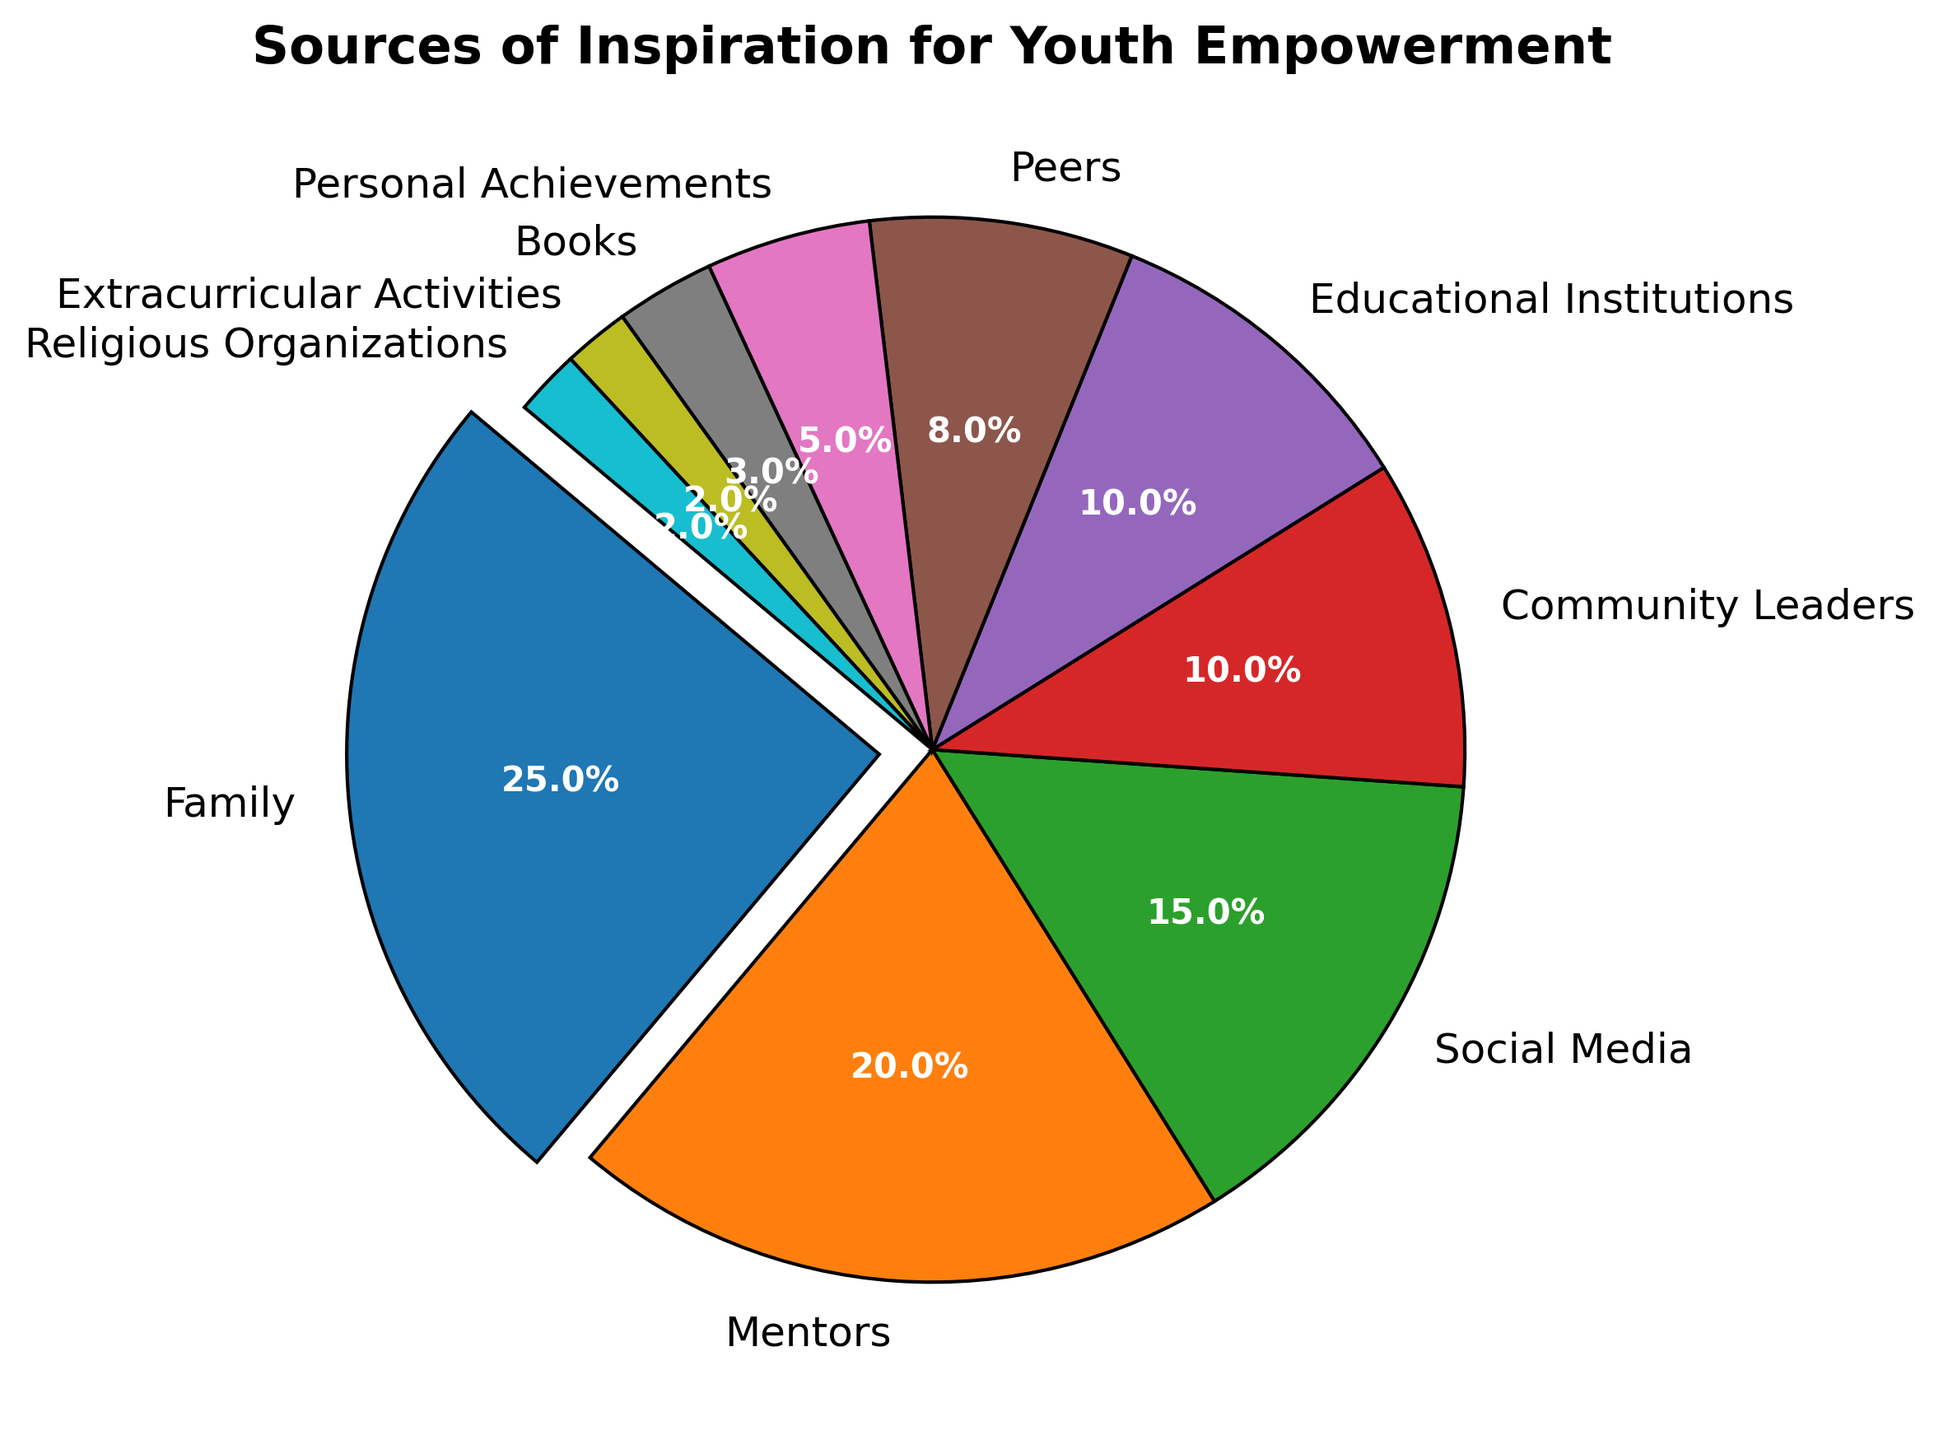What is the largest source of inspiration for youth empowerment? The pie chart shows the distribution of influences, and the largest section is clearly labeled as "Family" with 25%.
Answer: Family Which source of inspiration is the least influential? Among the listed sources, the smallest sections in the pie chart are labeled "Religious Organizations" and "Extracurricular Activities," both at 2%.
Answer: Religious Organizations and Extracurricular Activities Compare the influence of "Mentors" and "Social Media". Which one is higher? By looking at the pie chart, "Mentors" have a larger percentage (20%) compared to "Social Media," which is at 15%.
Answer: Mentors How much greater is the percentage of "Families" compared to "Community Leaders"? The slice for "Family" is 25%, while "Community Leaders" is 10%. So, 25% - 10% = 15%.
Answer: 15% What is the combined percentage of "Peers" and "Personal Achievements"? By summing the percentages: 8% (Peers) + 5% (Personal Achievements) = 13%.
Answer: 13% Which segment of the pie chart has an explosion effect and why? The slice for "Family" is separated slightly from the center, indicating it has the explosion effect to emphasize it as the largest source of inspiration.
Answer: Family How do the influences of "Books" compare to "Educational Institutions"? "Educational Institutions" account for 10%, while "Books" account for 3%. Therefore, "Educational Institutions" have a higher influence.
Answer: Educational Institutions What is the sum of the percentages for "Family", "Mentors", and "Social Media"? Adding up the percentages: 25% (Family) + 20% (Mentors) + 15% (Social Media) = 60%.
Answer: 60% If you sum up the percentages for "Educational Institutions", "Peers", and "Personal Achievements", what do you get? Adding their percentages: 10% (Educational Institutions) + 8% (Peers) + 5% (Personal Achievements) = 23%.
Answer: 23% Which category taken alone is responsible for more than one-fifth of the total influence? The pie chart section shows that only "Family" accounts for 25%, which is more than one-fifth (20%) of the total.
Answer: Family 